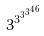Convert formula to latex. <formula><loc_0><loc_0><loc_500><loc_500>3 ^ { 3 ^ { 3 ^ { 3 ^ { 4 6 } } } }</formula> 